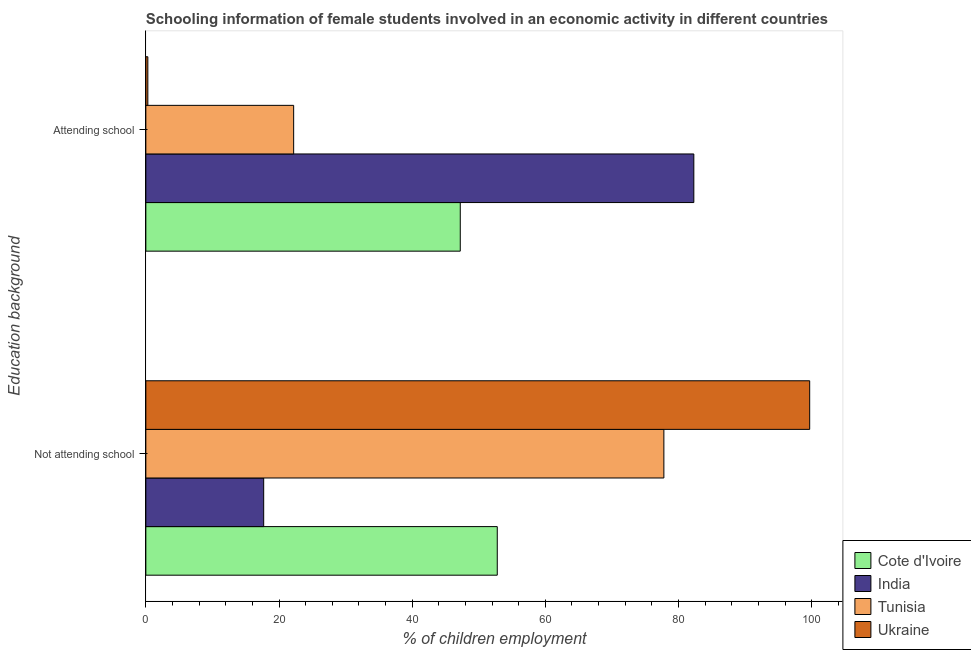How many bars are there on the 2nd tick from the bottom?
Provide a succinct answer. 4. What is the label of the 2nd group of bars from the top?
Give a very brief answer. Not attending school. What is the percentage of employed females who are attending school in India?
Keep it short and to the point. 82.3. Across all countries, what is the maximum percentage of employed females who are not attending school?
Keep it short and to the point. 99.7. In which country was the percentage of employed females who are not attending school minimum?
Your answer should be very brief. India. What is the total percentage of employed females who are attending school in the graph?
Provide a succinct answer. 152.02. What is the difference between the percentage of employed females who are attending school in Cote d'Ivoire and that in India?
Your response must be concise. -35.08. What is the difference between the percentage of employed females who are attending school in India and the percentage of employed females who are not attending school in Cote d'Ivoire?
Your response must be concise. 29.52. What is the average percentage of employed females who are attending school per country?
Ensure brevity in your answer.  38.01. What is the difference between the percentage of employed females who are not attending school and percentage of employed females who are attending school in Ukraine?
Your response must be concise. 99.4. What is the ratio of the percentage of employed females who are not attending school in Tunisia to that in India?
Give a very brief answer. 4.4. Is the percentage of employed females who are attending school in Cote d'Ivoire less than that in India?
Offer a very short reply. Yes. What does the 3rd bar from the top in Attending school represents?
Ensure brevity in your answer.  India. What does the 3rd bar from the bottom in Attending school represents?
Your response must be concise. Tunisia. Does the graph contain grids?
Ensure brevity in your answer.  No. Where does the legend appear in the graph?
Your response must be concise. Bottom right. What is the title of the graph?
Ensure brevity in your answer.  Schooling information of female students involved in an economic activity in different countries. What is the label or title of the X-axis?
Your response must be concise. % of children employment. What is the label or title of the Y-axis?
Your response must be concise. Education background. What is the % of children employment in Cote d'Ivoire in Not attending school?
Provide a succinct answer. 52.78. What is the % of children employment of Tunisia in Not attending school?
Ensure brevity in your answer.  77.8. What is the % of children employment of Ukraine in Not attending school?
Your response must be concise. 99.7. What is the % of children employment of Cote d'Ivoire in Attending school?
Your answer should be compact. 47.22. What is the % of children employment in India in Attending school?
Your answer should be compact. 82.3. What is the % of children employment in Tunisia in Attending school?
Your response must be concise. 22.2. Across all Education background, what is the maximum % of children employment of Cote d'Ivoire?
Ensure brevity in your answer.  52.78. Across all Education background, what is the maximum % of children employment of India?
Your answer should be very brief. 82.3. Across all Education background, what is the maximum % of children employment of Tunisia?
Make the answer very short. 77.8. Across all Education background, what is the maximum % of children employment of Ukraine?
Keep it short and to the point. 99.7. Across all Education background, what is the minimum % of children employment in Cote d'Ivoire?
Provide a short and direct response. 47.22. Across all Education background, what is the minimum % of children employment of India?
Make the answer very short. 17.7. Across all Education background, what is the minimum % of children employment of Tunisia?
Offer a very short reply. 22.2. Across all Education background, what is the minimum % of children employment in Ukraine?
Keep it short and to the point. 0.3. What is the total % of children employment in India in the graph?
Provide a short and direct response. 100. What is the difference between the % of children employment in Cote d'Ivoire in Not attending school and that in Attending school?
Give a very brief answer. 5.56. What is the difference between the % of children employment of India in Not attending school and that in Attending school?
Provide a short and direct response. -64.6. What is the difference between the % of children employment of Tunisia in Not attending school and that in Attending school?
Provide a succinct answer. 55.6. What is the difference between the % of children employment of Ukraine in Not attending school and that in Attending school?
Give a very brief answer. 99.4. What is the difference between the % of children employment of Cote d'Ivoire in Not attending school and the % of children employment of India in Attending school?
Offer a very short reply. -29.52. What is the difference between the % of children employment in Cote d'Ivoire in Not attending school and the % of children employment in Tunisia in Attending school?
Your answer should be compact. 30.58. What is the difference between the % of children employment in Cote d'Ivoire in Not attending school and the % of children employment in Ukraine in Attending school?
Ensure brevity in your answer.  52.48. What is the difference between the % of children employment in India in Not attending school and the % of children employment in Ukraine in Attending school?
Give a very brief answer. 17.4. What is the difference between the % of children employment in Tunisia in Not attending school and the % of children employment in Ukraine in Attending school?
Your answer should be very brief. 77.5. What is the average % of children employment in India per Education background?
Offer a terse response. 50. What is the average % of children employment of Ukraine per Education background?
Your answer should be compact. 50. What is the difference between the % of children employment in Cote d'Ivoire and % of children employment in India in Not attending school?
Your response must be concise. 35.08. What is the difference between the % of children employment of Cote d'Ivoire and % of children employment of Tunisia in Not attending school?
Keep it short and to the point. -25.02. What is the difference between the % of children employment of Cote d'Ivoire and % of children employment of Ukraine in Not attending school?
Keep it short and to the point. -46.92. What is the difference between the % of children employment in India and % of children employment in Tunisia in Not attending school?
Ensure brevity in your answer.  -60.1. What is the difference between the % of children employment in India and % of children employment in Ukraine in Not attending school?
Your answer should be very brief. -82. What is the difference between the % of children employment in Tunisia and % of children employment in Ukraine in Not attending school?
Keep it short and to the point. -21.9. What is the difference between the % of children employment of Cote d'Ivoire and % of children employment of India in Attending school?
Provide a succinct answer. -35.08. What is the difference between the % of children employment in Cote d'Ivoire and % of children employment in Tunisia in Attending school?
Provide a succinct answer. 25.02. What is the difference between the % of children employment of Cote d'Ivoire and % of children employment of Ukraine in Attending school?
Your answer should be very brief. 46.92. What is the difference between the % of children employment in India and % of children employment in Tunisia in Attending school?
Provide a short and direct response. 60.1. What is the difference between the % of children employment in Tunisia and % of children employment in Ukraine in Attending school?
Make the answer very short. 21.9. What is the ratio of the % of children employment of Cote d'Ivoire in Not attending school to that in Attending school?
Give a very brief answer. 1.12. What is the ratio of the % of children employment in India in Not attending school to that in Attending school?
Offer a terse response. 0.22. What is the ratio of the % of children employment in Tunisia in Not attending school to that in Attending school?
Provide a short and direct response. 3.5. What is the ratio of the % of children employment in Ukraine in Not attending school to that in Attending school?
Offer a very short reply. 332.33. What is the difference between the highest and the second highest % of children employment in Cote d'Ivoire?
Keep it short and to the point. 5.56. What is the difference between the highest and the second highest % of children employment in India?
Your response must be concise. 64.6. What is the difference between the highest and the second highest % of children employment in Tunisia?
Offer a terse response. 55.6. What is the difference between the highest and the second highest % of children employment in Ukraine?
Provide a short and direct response. 99.4. What is the difference between the highest and the lowest % of children employment of Cote d'Ivoire?
Offer a terse response. 5.56. What is the difference between the highest and the lowest % of children employment in India?
Give a very brief answer. 64.6. What is the difference between the highest and the lowest % of children employment in Tunisia?
Make the answer very short. 55.6. What is the difference between the highest and the lowest % of children employment in Ukraine?
Ensure brevity in your answer.  99.4. 